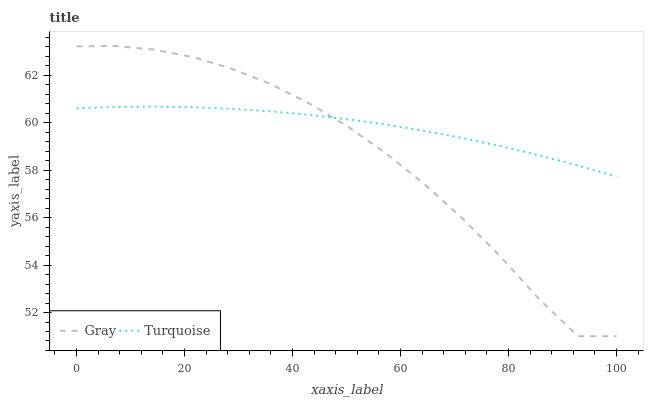Does Gray have the minimum area under the curve?
Answer yes or no. Yes. Does Turquoise have the maximum area under the curve?
Answer yes or no. Yes. Does Turquoise have the minimum area under the curve?
Answer yes or no. No. Is Turquoise the smoothest?
Answer yes or no. Yes. Is Gray the roughest?
Answer yes or no. Yes. Is Turquoise the roughest?
Answer yes or no. No. Does Turquoise have the lowest value?
Answer yes or no. No. Does Gray have the highest value?
Answer yes or no. Yes. Does Turquoise have the highest value?
Answer yes or no. No. Does Gray intersect Turquoise?
Answer yes or no. Yes. Is Gray less than Turquoise?
Answer yes or no. No. Is Gray greater than Turquoise?
Answer yes or no. No. 